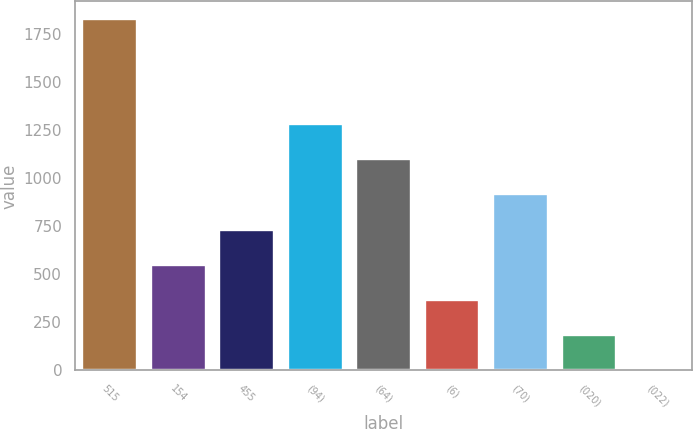<chart> <loc_0><loc_0><loc_500><loc_500><bar_chart><fcel>515<fcel>154<fcel>455<fcel>(94)<fcel>(64)<fcel>(6)<fcel>(70)<fcel>(020)<fcel>(022)<nl><fcel>1827<fcel>549.68<fcel>732.15<fcel>1279.56<fcel>1097.09<fcel>367.21<fcel>914.62<fcel>184.74<fcel>2.27<nl></chart> 